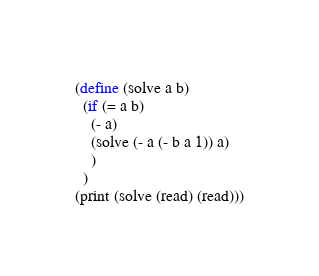<code> <loc_0><loc_0><loc_500><loc_500><_Scheme_>(define (solve a b)
  (if (= a b)
    (- a)
    (solve (- a (- b a 1)) a)
    )
  )
(print (solve (read) (read)))</code> 